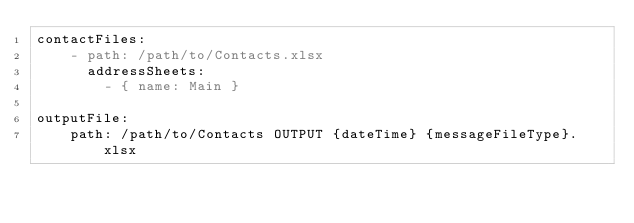<code> <loc_0><loc_0><loc_500><loc_500><_YAML_>contactFiles:
    - path: /path/to/Contacts.xlsx
      addressSheets:
        - { name: Main }

outputFile:
    path: /path/to/Contacts OUTPUT {dateTime} {messageFileType}.xlsx
</code> 